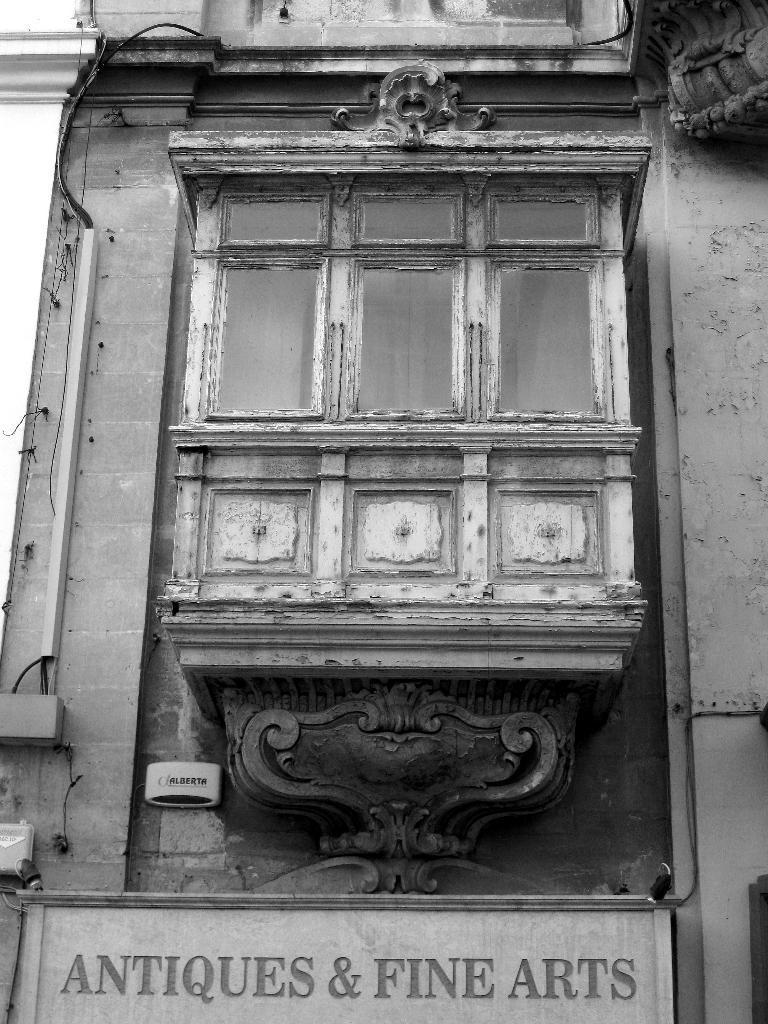Please provide a concise description of this image. This is a black and white image. At the bottom there is a board on which I can see some text. In the middle of the image there is a wooden box attached to the wall. 